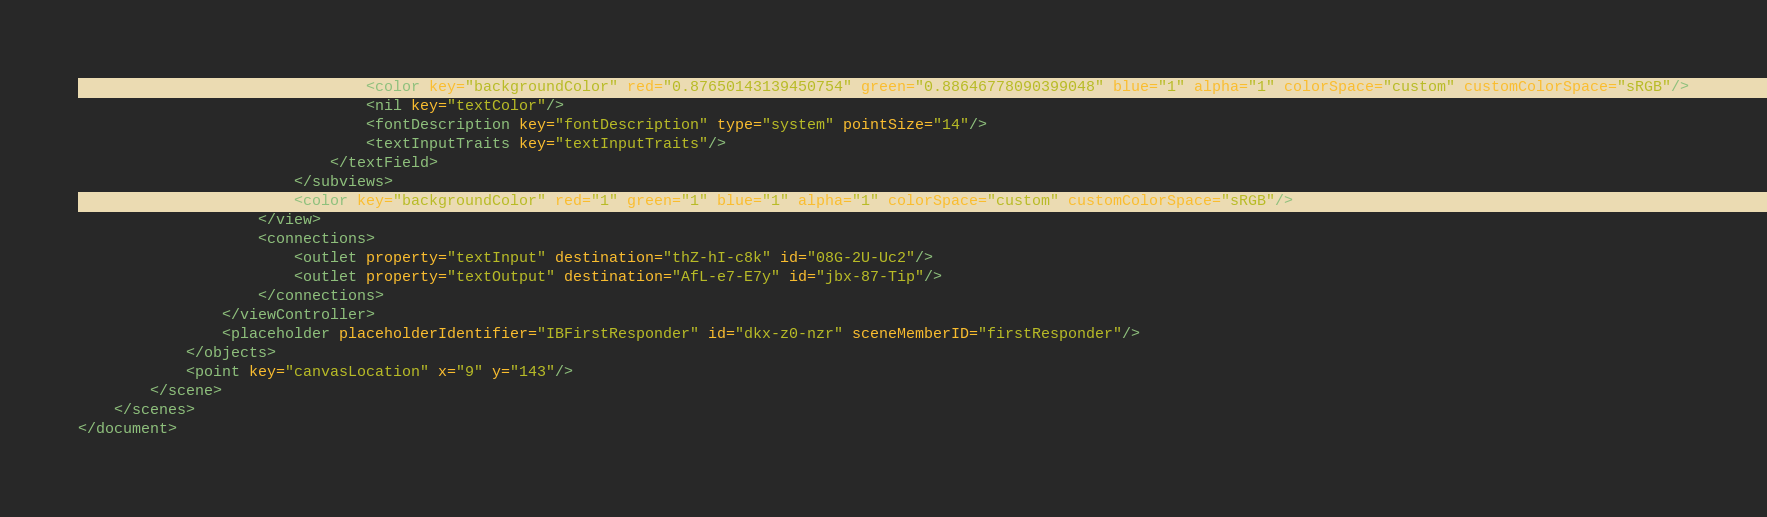Convert code to text. <code><loc_0><loc_0><loc_500><loc_500><_XML_>                                <color key="backgroundColor" red="0.87650143139450754" green="0.88646778090399048" blue="1" alpha="1" colorSpace="custom" customColorSpace="sRGB"/>
                                <nil key="textColor"/>
                                <fontDescription key="fontDescription" type="system" pointSize="14"/>
                                <textInputTraits key="textInputTraits"/>
                            </textField>
                        </subviews>
                        <color key="backgroundColor" red="1" green="1" blue="1" alpha="1" colorSpace="custom" customColorSpace="sRGB"/>
                    </view>
                    <connections>
                        <outlet property="textInput" destination="thZ-hI-c8k" id="08G-2U-Uc2"/>
                        <outlet property="textOutput" destination="AfL-e7-E7y" id="jbx-87-Tip"/>
                    </connections>
                </viewController>
                <placeholder placeholderIdentifier="IBFirstResponder" id="dkx-z0-nzr" sceneMemberID="firstResponder"/>
            </objects>
            <point key="canvasLocation" x="9" y="143"/>
        </scene>
    </scenes>
</document>
</code> 